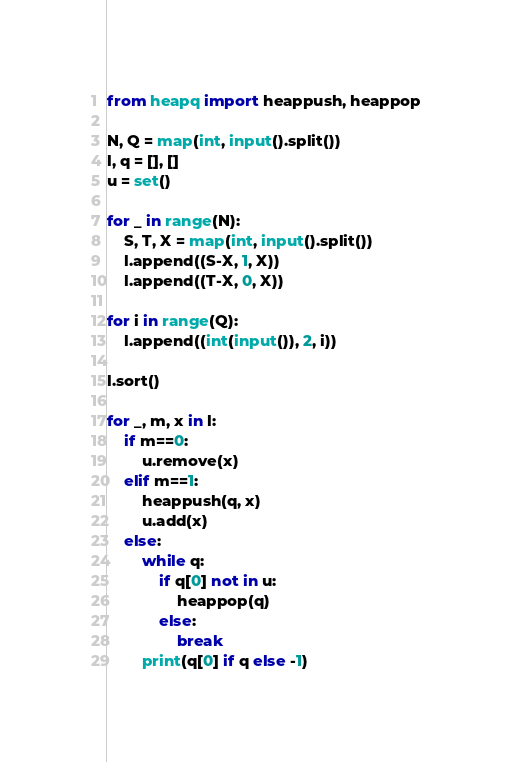Convert code to text. <code><loc_0><loc_0><loc_500><loc_500><_Python_>from heapq import heappush, heappop

N, Q = map(int, input().split())
l, q = [], []
u = set()

for _ in range(N):
    S, T, X = map(int, input().split())
    l.append((S-X, 1, X))
    l.append((T-X, 0, X))

for i in range(Q):
    l.append((int(input()), 2, i))

l.sort()

for _, m, x in l:
    if m==0:
        u.remove(x)
    elif m==1:
        heappush(q, x)
        u.add(x)
    else:
        while q:
            if q[0] not in u:
                heappop(q)
            else:
                break
        print(q[0] if q else -1)
</code> 